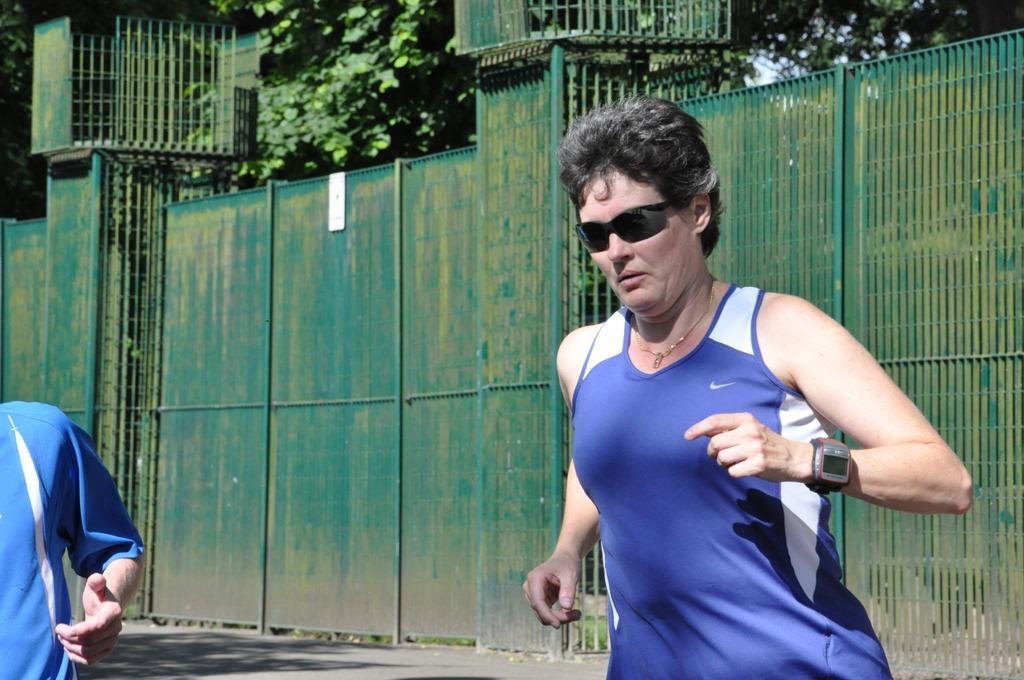Could you give a brief overview of what you see in this image? In this image we can see a lady wearing goggles and watch. Also there is another person. In the back there is a fencing. Also there are trees. 